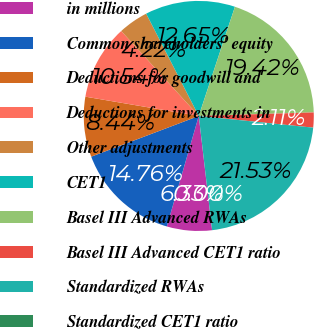Convert chart to OTSL. <chart><loc_0><loc_0><loc_500><loc_500><pie_chart><fcel>in millions<fcel>Common shareholders' equity<fcel>Deductions for goodwill and<fcel>Deductions for investments in<fcel>Other adjustments<fcel>CET1<fcel>Basel III Advanced RWAs<fcel>Basel III Advanced CET1 ratio<fcel>Standardized RWAs<fcel>Standardized CET1 ratio<nl><fcel>6.33%<fcel>14.76%<fcel>8.44%<fcel>10.54%<fcel>4.22%<fcel>12.65%<fcel>19.42%<fcel>2.11%<fcel>21.53%<fcel>0.0%<nl></chart> 